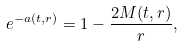<formula> <loc_0><loc_0><loc_500><loc_500>e ^ { - a ( t , r ) } = 1 - \frac { 2 M ( t , r ) } { r } ,</formula> 